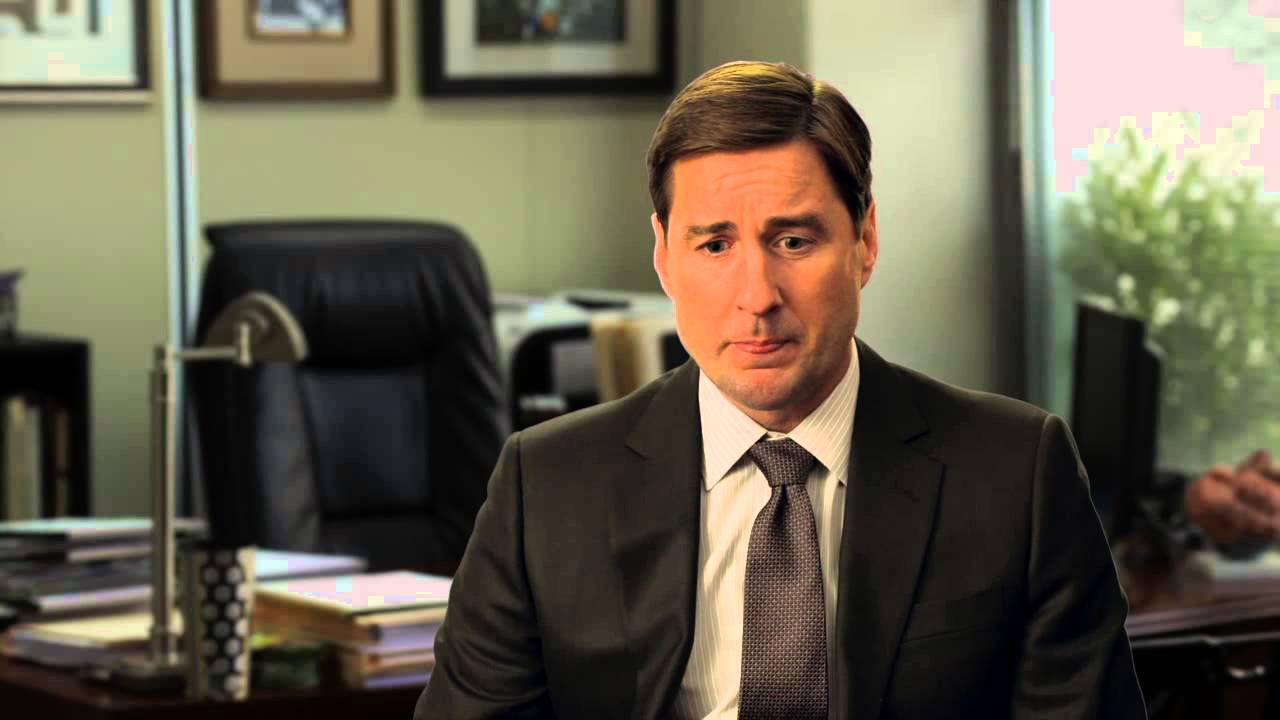What might this person be thinking about? He might be contemplating an important business decision or reflecting on a conversation he had recently. The seriousness of his expression conveys deep thought. 